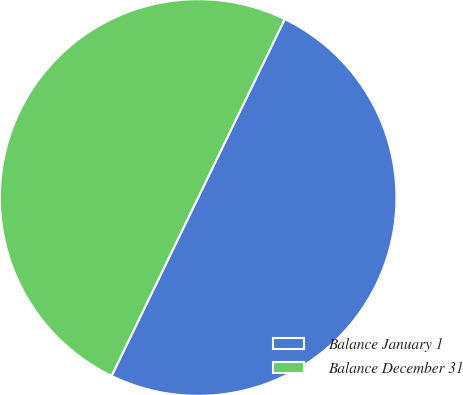<chart> <loc_0><loc_0><loc_500><loc_500><pie_chart><fcel>Balance January 1<fcel>Balance December 31<nl><fcel>50.0%<fcel>50.0%<nl></chart> 